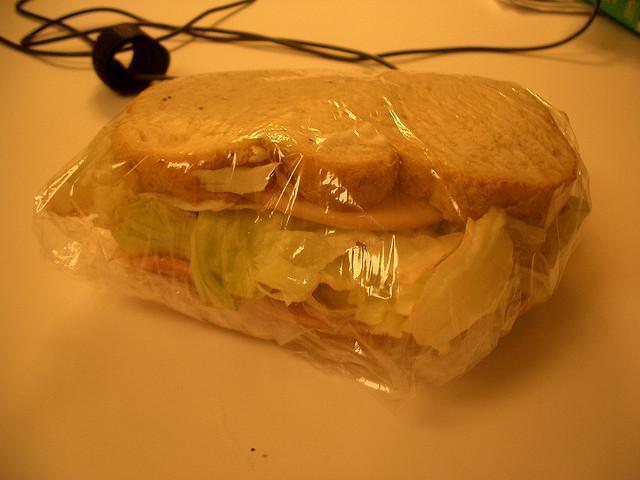How many squid-shaped kites can be seen?
Give a very brief answer. 0. 